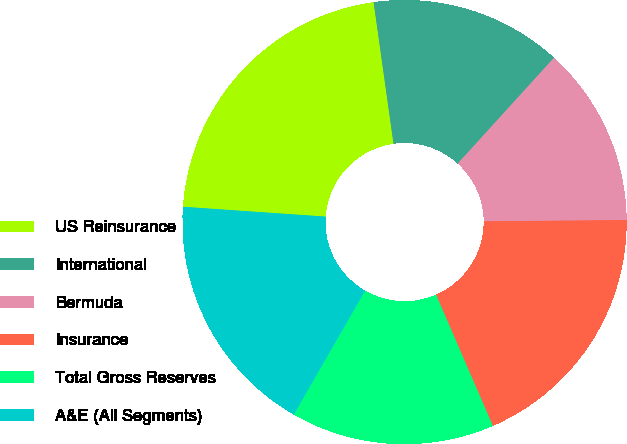Convert chart. <chart><loc_0><loc_0><loc_500><loc_500><pie_chart><fcel>US Reinsurance<fcel>International<fcel>Bermuda<fcel>Insurance<fcel>Total Gross Reserves<fcel>A&E (All Segments)<nl><fcel>21.68%<fcel>13.97%<fcel>13.11%<fcel>18.64%<fcel>14.82%<fcel>17.78%<nl></chart> 